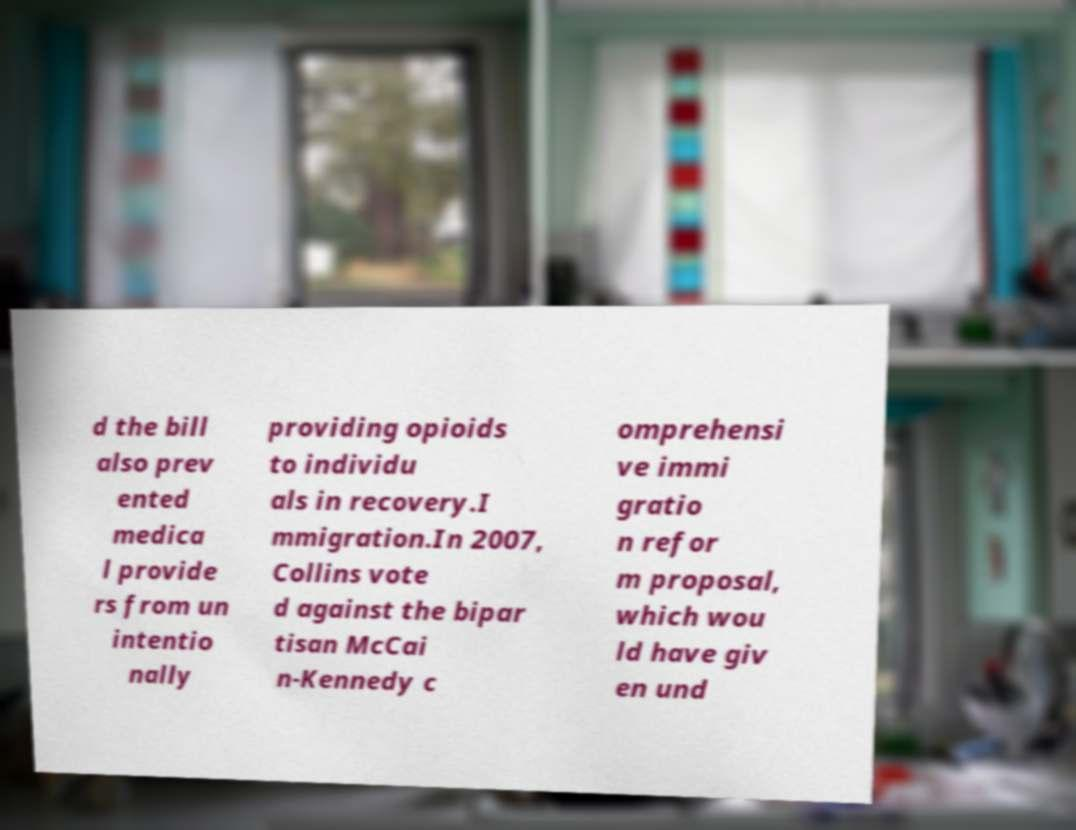Could you extract and type out the text from this image? d the bill also prev ented medica l provide rs from un intentio nally providing opioids to individu als in recovery.I mmigration.In 2007, Collins vote d against the bipar tisan McCai n-Kennedy c omprehensi ve immi gratio n refor m proposal, which wou ld have giv en und 